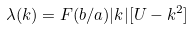<formula> <loc_0><loc_0><loc_500><loc_500>\lambda ( k ) = F ( b / a ) | k | [ U - k ^ { 2 } ]</formula> 